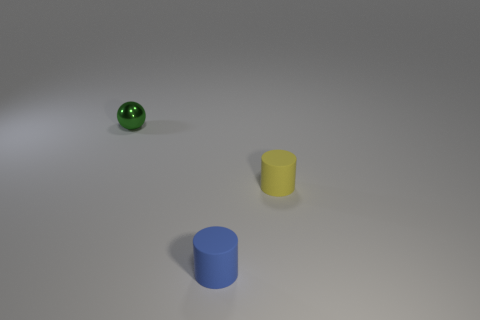The small thing that is left of the yellow cylinder and on the right side of the ball has what shape?
Provide a short and direct response. Cylinder. How many blue cylinders have the same material as the tiny yellow cylinder?
Keep it short and to the point. 1. What number of blue rubber cylinders are right of the small matte thing that is left of the yellow object?
Offer a very short reply. 0. There is a small object that is in front of the cylinder behind the rubber thing left of the yellow object; what shape is it?
Your answer should be compact. Cylinder. What number of things are small blue cylinders or large gray spheres?
Give a very brief answer. 1. There is a shiny thing that is the same size as the blue matte cylinder; what color is it?
Offer a very short reply. Green. Is the shape of the yellow matte object the same as the small matte thing that is to the left of the yellow matte cylinder?
Offer a terse response. Yes. What number of objects are cylinders that are to the left of the yellow rubber object or things that are behind the small blue matte thing?
Offer a very short reply. 3. The object behind the yellow thing has what shape?
Your answer should be compact. Sphere. Is the shape of the tiny object right of the tiny blue object the same as  the blue rubber object?
Keep it short and to the point. Yes. 